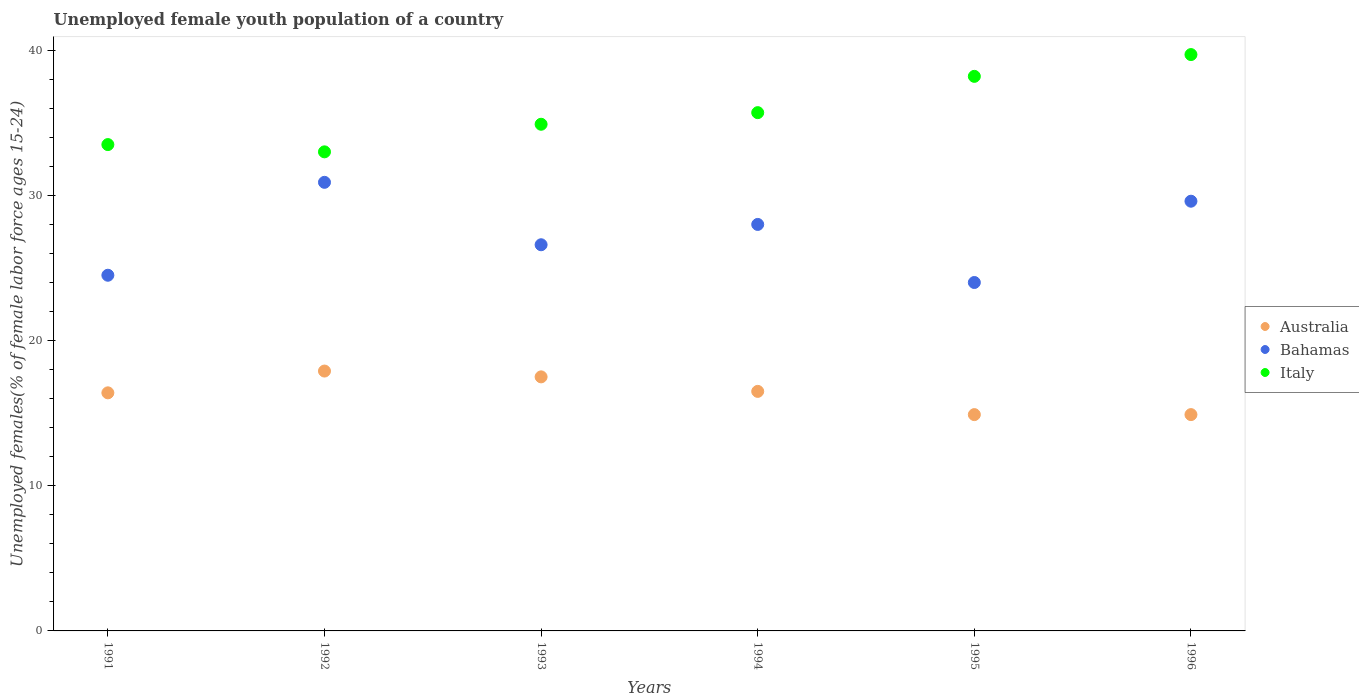Is the number of dotlines equal to the number of legend labels?
Your answer should be compact. Yes. What is the percentage of unemployed female youth population in Italy in 1991?
Offer a terse response. 33.5. Across all years, what is the maximum percentage of unemployed female youth population in Australia?
Your answer should be very brief. 17.9. Across all years, what is the minimum percentage of unemployed female youth population in Australia?
Make the answer very short. 14.9. In which year was the percentage of unemployed female youth population in Australia minimum?
Offer a terse response. 1995. What is the total percentage of unemployed female youth population in Italy in the graph?
Offer a terse response. 215. What is the difference between the percentage of unemployed female youth population in Italy in 1991 and that in 1993?
Provide a succinct answer. -1.4. What is the difference between the percentage of unemployed female youth population in Italy in 1991 and the percentage of unemployed female youth population in Bahamas in 1996?
Give a very brief answer. 3.9. What is the average percentage of unemployed female youth population in Australia per year?
Provide a short and direct response. 16.35. In the year 1995, what is the difference between the percentage of unemployed female youth population in Bahamas and percentage of unemployed female youth population in Italy?
Offer a terse response. -14.2. What is the ratio of the percentage of unemployed female youth population in Australia in 1991 to that in 1993?
Provide a succinct answer. 0.94. Is the percentage of unemployed female youth population in Australia in 1991 less than that in 1992?
Make the answer very short. Yes. What is the difference between the highest and the second highest percentage of unemployed female youth population in Australia?
Make the answer very short. 0.4. What is the difference between the highest and the lowest percentage of unemployed female youth population in Australia?
Make the answer very short. 3. Is it the case that in every year, the sum of the percentage of unemployed female youth population in Australia and percentage of unemployed female youth population in Bahamas  is greater than the percentage of unemployed female youth population in Italy?
Offer a terse response. Yes. Is the percentage of unemployed female youth population in Italy strictly less than the percentage of unemployed female youth population in Bahamas over the years?
Provide a short and direct response. No. How many dotlines are there?
Provide a short and direct response. 3. How many years are there in the graph?
Keep it short and to the point. 6. What is the difference between two consecutive major ticks on the Y-axis?
Your answer should be very brief. 10. Does the graph contain grids?
Give a very brief answer. No. What is the title of the graph?
Make the answer very short. Unemployed female youth population of a country. Does "Papua New Guinea" appear as one of the legend labels in the graph?
Your answer should be compact. No. What is the label or title of the X-axis?
Offer a very short reply. Years. What is the label or title of the Y-axis?
Provide a short and direct response. Unemployed females(% of female labor force ages 15-24). What is the Unemployed females(% of female labor force ages 15-24) in Australia in 1991?
Your answer should be very brief. 16.4. What is the Unemployed females(% of female labor force ages 15-24) in Italy in 1991?
Make the answer very short. 33.5. What is the Unemployed females(% of female labor force ages 15-24) of Australia in 1992?
Your response must be concise. 17.9. What is the Unemployed females(% of female labor force ages 15-24) in Bahamas in 1992?
Keep it short and to the point. 30.9. What is the Unemployed females(% of female labor force ages 15-24) in Italy in 1992?
Make the answer very short. 33. What is the Unemployed females(% of female labor force ages 15-24) in Bahamas in 1993?
Provide a short and direct response. 26.6. What is the Unemployed females(% of female labor force ages 15-24) in Italy in 1993?
Offer a very short reply. 34.9. What is the Unemployed females(% of female labor force ages 15-24) in Bahamas in 1994?
Give a very brief answer. 28. What is the Unemployed females(% of female labor force ages 15-24) of Italy in 1994?
Make the answer very short. 35.7. What is the Unemployed females(% of female labor force ages 15-24) in Australia in 1995?
Your response must be concise. 14.9. What is the Unemployed females(% of female labor force ages 15-24) in Bahamas in 1995?
Provide a short and direct response. 24. What is the Unemployed females(% of female labor force ages 15-24) in Italy in 1995?
Keep it short and to the point. 38.2. What is the Unemployed females(% of female labor force ages 15-24) in Australia in 1996?
Ensure brevity in your answer.  14.9. What is the Unemployed females(% of female labor force ages 15-24) of Bahamas in 1996?
Your answer should be compact. 29.6. What is the Unemployed females(% of female labor force ages 15-24) in Italy in 1996?
Your response must be concise. 39.7. Across all years, what is the maximum Unemployed females(% of female labor force ages 15-24) of Australia?
Make the answer very short. 17.9. Across all years, what is the maximum Unemployed females(% of female labor force ages 15-24) in Bahamas?
Your answer should be very brief. 30.9. Across all years, what is the maximum Unemployed females(% of female labor force ages 15-24) of Italy?
Provide a succinct answer. 39.7. Across all years, what is the minimum Unemployed females(% of female labor force ages 15-24) of Australia?
Ensure brevity in your answer.  14.9. Across all years, what is the minimum Unemployed females(% of female labor force ages 15-24) of Bahamas?
Your answer should be compact. 24. Across all years, what is the minimum Unemployed females(% of female labor force ages 15-24) of Italy?
Keep it short and to the point. 33. What is the total Unemployed females(% of female labor force ages 15-24) of Australia in the graph?
Your response must be concise. 98.1. What is the total Unemployed females(% of female labor force ages 15-24) of Bahamas in the graph?
Offer a very short reply. 163.6. What is the total Unemployed females(% of female labor force ages 15-24) of Italy in the graph?
Keep it short and to the point. 215. What is the difference between the Unemployed females(% of female labor force ages 15-24) of Italy in 1991 and that in 1992?
Offer a terse response. 0.5. What is the difference between the Unemployed females(% of female labor force ages 15-24) of Australia in 1991 and that in 1994?
Your answer should be compact. -0.1. What is the difference between the Unemployed females(% of female labor force ages 15-24) of Italy in 1991 and that in 1994?
Make the answer very short. -2.2. What is the difference between the Unemployed females(% of female labor force ages 15-24) of Italy in 1991 and that in 1995?
Ensure brevity in your answer.  -4.7. What is the difference between the Unemployed females(% of female labor force ages 15-24) of Italy in 1991 and that in 1996?
Offer a very short reply. -6.2. What is the difference between the Unemployed females(% of female labor force ages 15-24) of Italy in 1992 and that in 1994?
Offer a very short reply. -2.7. What is the difference between the Unemployed females(% of female labor force ages 15-24) of Bahamas in 1992 and that in 1995?
Provide a succinct answer. 6.9. What is the difference between the Unemployed females(% of female labor force ages 15-24) of Italy in 1992 and that in 1995?
Provide a succinct answer. -5.2. What is the difference between the Unemployed females(% of female labor force ages 15-24) of Australia in 1992 and that in 1996?
Ensure brevity in your answer.  3. What is the difference between the Unemployed females(% of female labor force ages 15-24) of Bahamas in 1992 and that in 1996?
Give a very brief answer. 1.3. What is the difference between the Unemployed females(% of female labor force ages 15-24) of Italy in 1992 and that in 1996?
Ensure brevity in your answer.  -6.7. What is the difference between the Unemployed females(% of female labor force ages 15-24) of Bahamas in 1993 and that in 1995?
Give a very brief answer. 2.6. What is the difference between the Unemployed females(% of female labor force ages 15-24) of Italy in 1993 and that in 1995?
Provide a short and direct response. -3.3. What is the difference between the Unemployed females(% of female labor force ages 15-24) of Bahamas in 1993 and that in 1996?
Make the answer very short. -3. What is the difference between the Unemployed females(% of female labor force ages 15-24) of Italy in 1993 and that in 1996?
Your response must be concise. -4.8. What is the difference between the Unemployed females(% of female labor force ages 15-24) of Australia in 1994 and that in 1996?
Your response must be concise. 1.6. What is the difference between the Unemployed females(% of female labor force ages 15-24) in Italy in 1994 and that in 1996?
Provide a succinct answer. -4. What is the difference between the Unemployed females(% of female labor force ages 15-24) of Bahamas in 1995 and that in 1996?
Give a very brief answer. -5.6. What is the difference between the Unemployed females(% of female labor force ages 15-24) of Australia in 1991 and the Unemployed females(% of female labor force ages 15-24) of Bahamas in 1992?
Provide a succinct answer. -14.5. What is the difference between the Unemployed females(% of female labor force ages 15-24) of Australia in 1991 and the Unemployed females(% of female labor force ages 15-24) of Italy in 1992?
Your answer should be compact. -16.6. What is the difference between the Unemployed females(% of female labor force ages 15-24) of Bahamas in 1991 and the Unemployed females(% of female labor force ages 15-24) of Italy in 1992?
Your answer should be compact. -8.5. What is the difference between the Unemployed females(% of female labor force ages 15-24) of Australia in 1991 and the Unemployed females(% of female labor force ages 15-24) of Italy in 1993?
Your response must be concise. -18.5. What is the difference between the Unemployed females(% of female labor force ages 15-24) of Australia in 1991 and the Unemployed females(% of female labor force ages 15-24) of Italy in 1994?
Provide a succinct answer. -19.3. What is the difference between the Unemployed females(% of female labor force ages 15-24) of Australia in 1991 and the Unemployed females(% of female labor force ages 15-24) of Bahamas in 1995?
Offer a very short reply. -7.6. What is the difference between the Unemployed females(% of female labor force ages 15-24) of Australia in 1991 and the Unemployed females(% of female labor force ages 15-24) of Italy in 1995?
Your answer should be compact. -21.8. What is the difference between the Unemployed females(% of female labor force ages 15-24) in Bahamas in 1991 and the Unemployed females(% of female labor force ages 15-24) in Italy in 1995?
Make the answer very short. -13.7. What is the difference between the Unemployed females(% of female labor force ages 15-24) in Australia in 1991 and the Unemployed females(% of female labor force ages 15-24) in Bahamas in 1996?
Keep it short and to the point. -13.2. What is the difference between the Unemployed females(% of female labor force ages 15-24) of Australia in 1991 and the Unemployed females(% of female labor force ages 15-24) of Italy in 1996?
Keep it short and to the point. -23.3. What is the difference between the Unemployed females(% of female labor force ages 15-24) in Bahamas in 1991 and the Unemployed females(% of female labor force ages 15-24) in Italy in 1996?
Give a very brief answer. -15.2. What is the difference between the Unemployed females(% of female labor force ages 15-24) of Bahamas in 1992 and the Unemployed females(% of female labor force ages 15-24) of Italy in 1993?
Your response must be concise. -4. What is the difference between the Unemployed females(% of female labor force ages 15-24) in Australia in 1992 and the Unemployed females(% of female labor force ages 15-24) in Bahamas in 1994?
Your answer should be compact. -10.1. What is the difference between the Unemployed females(% of female labor force ages 15-24) of Australia in 1992 and the Unemployed females(% of female labor force ages 15-24) of Italy in 1994?
Offer a very short reply. -17.8. What is the difference between the Unemployed females(% of female labor force ages 15-24) of Bahamas in 1992 and the Unemployed females(% of female labor force ages 15-24) of Italy in 1994?
Your answer should be compact. -4.8. What is the difference between the Unemployed females(% of female labor force ages 15-24) in Australia in 1992 and the Unemployed females(% of female labor force ages 15-24) in Italy in 1995?
Make the answer very short. -20.3. What is the difference between the Unemployed females(% of female labor force ages 15-24) of Australia in 1992 and the Unemployed females(% of female labor force ages 15-24) of Bahamas in 1996?
Your answer should be very brief. -11.7. What is the difference between the Unemployed females(% of female labor force ages 15-24) in Australia in 1992 and the Unemployed females(% of female labor force ages 15-24) in Italy in 1996?
Offer a very short reply. -21.8. What is the difference between the Unemployed females(% of female labor force ages 15-24) in Australia in 1993 and the Unemployed females(% of female labor force ages 15-24) in Bahamas in 1994?
Offer a terse response. -10.5. What is the difference between the Unemployed females(% of female labor force ages 15-24) in Australia in 1993 and the Unemployed females(% of female labor force ages 15-24) in Italy in 1994?
Provide a succinct answer. -18.2. What is the difference between the Unemployed females(% of female labor force ages 15-24) of Australia in 1993 and the Unemployed females(% of female labor force ages 15-24) of Bahamas in 1995?
Keep it short and to the point. -6.5. What is the difference between the Unemployed females(% of female labor force ages 15-24) in Australia in 1993 and the Unemployed females(% of female labor force ages 15-24) in Italy in 1995?
Your answer should be very brief. -20.7. What is the difference between the Unemployed females(% of female labor force ages 15-24) of Bahamas in 1993 and the Unemployed females(% of female labor force ages 15-24) of Italy in 1995?
Your answer should be compact. -11.6. What is the difference between the Unemployed females(% of female labor force ages 15-24) in Australia in 1993 and the Unemployed females(% of female labor force ages 15-24) in Bahamas in 1996?
Keep it short and to the point. -12.1. What is the difference between the Unemployed females(% of female labor force ages 15-24) in Australia in 1993 and the Unemployed females(% of female labor force ages 15-24) in Italy in 1996?
Offer a very short reply. -22.2. What is the difference between the Unemployed females(% of female labor force ages 15-24) of Australia in 1994 and the Unemployed females(% of female labor force ages 15-24) of Italy in 1995?
Your response must be concise. -21.7. What is the difference between the Unemployed females(% of female labor force ages 15-24) of Bahamas in 1994 and the Unemployed females(% of female labor force ages 15-24) of Italy in 1995?
Your response must be concise. -10.2. What is the difference between the Unemployed females(% of female labor force ages 15-24) in Australia in 1994 and the Unemployed females(% of female labor force ages 15-24) in Italy in 1996?
Make the answer very short. -23.2. What is the difference between the Unemployed females(% of female labor force ages 15-24) of Bahamas in 1994 and the Unemployed females(% of female labor force ages 15-24) of Italy in 1996?
Provide a succinct answer. -11.7. What is the difference between the Unemployed females(% of female labor force ages 15-24) in Australia in 1995 and the Unemployed females(% of female labor force ages 15-24) in Bahamas in 1996?
Your response must be concise. -14.7. What is the difference between the Unemployed females(% of female labor force ages 15-24) of Australia in 1995 and the Unemployed females(% of female labor force ages 15-24) of Italy in 1996?
Give a very brief answer. -24.8. What is the difference between the Unemployed females(% of female labor force ages 15-24) in Bahamas in 1995 and the Unemployed females(% of female labor force ages 15-24) in Italy in 1996?
Offer a terse response. -15.7. What is the average Unemployed females(% of female labor force ages 15-24) of Australia per year?
Keep it short and to the point. 16.35. What is the average Unemployed females(% of female labor force ages 15-24) of Bahamas per year?
Make the answer very short. 27.27. What is the average Unemployed females(% of female labor force ages 15-24) in Italy per year?
Provide a short and direct response. 35.83. In the year 1991, what is the difference between the Unemployed females(% of female labor force ages 15-24) in Australia and Unemployed females(% of female labor force ages 15-24) in Italy?
Keep it short and to the point. -17.1. In the year 1992, what is the difference between the Unemployed females(% of female labor force ages 15-24) of Australia and Unemployed females(% of female labor force ages 15-24) of Italy?
Offer a very short reply. -15.1. In the year 1993, what is the difference between the Unemployed females(% of female labor force ages 15-24) of Australia and Unemployed females(% of female labor force ages 15-24) of Italy?
Offer a very short reply. -17.4. In the year 1994, what is the difference between the Unemployed females(% of female labor force ages 15-24) of Australia and Unemployed females(% of female labor force ages 15-24) of Italy?
Provide a short and direct response. -19.2. In the year 1995, what is the difference between the Unemployed females(% of female labor force ages 15-24) of Australia and Unemployed females(% of female labor force ages 15-24) of Bahamas?
Give a very brief answer. -9.1. In the year 1995, what is the difference between the Unemployed females(% of female labor force ages 15-24) in Australia and Unemployed females(% of female labor force ages 15-24) in Italy?
Keep it short and to the point. -23.3. In the year 1996, what is the difference between the Unemployed females(% of female labor force ages 15-24) in Australia and Unemployed females(% of female labor force ages 15-24) in Bahamas?
Ensure brevity in your answer.  -14.7. In the year 1996, what is the difference between the Unemployed females(% of female labor force ages 15-24) of Australia and Unemployed females(% of female labor force ages 15-24) of Italy?
Keep it short and to the point. -24.8. In the year 1996, what is the difference between the Unemployed females(% of female labor force ages 15-24) of Bahamas and Unemployed females(% of female labor force ages 15-24) of Italy?
Offer a very short reply. -10.1. What is the ratio of the Unemployed females(% of female labor force ages 15-24) in Australia in 1991 to that in 1992?
Your answer should be compact. 0.92. What is the ratio of the Unemployed females(% of female labor force ages 15-24) of Bahamas in 1991 to that in 1992?
Make the answer very short. 0.79. What is the ratio of the Unemployed females(% of female labor force ages 15-24) in Italy in 1991 to that in 1992?
Give a very brief answer. 1.02. What is the ratio of the Unemployed females(% of female labor force ages 15-24) of Australia in 1991 to that in 1993?
Provide a short and direct response. 0.94. What is the ratio of the Unemployed females(% of female labor force ages 15-24) of Bahamas in 1991 to that in 1993?
Provide a short and direct response. 0.92. What is the ratio of the Unemployed females(% of female labor force ages 15-24) in Italy in 1991 to that in 1993?
Offer a very short reply. 0.96. What is the ratio of the Unemployed females(% of female labor force ages 15-24) of Australia in 1991 to that in 1994?
Your answer should be very brief. 0.99. What is the ratio of the Unemployed females(% of female labor force ages 15-24) in Bahamas in 1991 to that in 1994?
Your answer should be compact. 0.88. What is the ratio of the Unemployed females(% of female labor force ages 15-24) in Italy in 1991 to that in 1994?
Make the answer very short. 0.94. What is the ratio of the Unemployed females(% of female labor force ages 15-24) in Australia in 1991 to that in 1995?
Your answer should be compact. 1.1. What is the ratio of the Unemployed females(% of female labor force ages 15-24) of Bahamas in 1991 to that in 1995?
Your response must be concise. 1.02. What is the ratio of the Unemployed females(% of female labor force ages 15-24) in Italy in 1991 to that in 1995?
Your answer should be compact. 0.88. What is the ratio of the Unemployed females(% of female labor force ages 15-24) of Australia in 1991 to that in 1996?
Make the answer very short. 1.1. What is the ratio of the Unemployed females(% of female labor force ages 15-24) of Bahamas in 1991 to that in 1996?
Ensure brevity in your answer.  0.83. What is the ratio of the Unemployed females(% of female labor force ages 15-24) of Italy in 1991 to that in 1996?
Ensure brevity in your answer.  0.84. What is the ratio of the Unemployed females(% of female labor force ages 15-24) of Australia in 1992 to that in 1993?
Provide a short and direct response. 1.02. What is the ratio of the Unemployed females(% of female labor force ages 15-24) in Bahamas in 1992 to that in 1993?
Provide a short and direct response. 1.16. What is the ratio of the Unemployed females(% of female labor force ages 15-24) of Italy in 1992 to that in 1993?
Give a very brief answer. 0.95. What is the ratio of the Unemployed females(% of female labor force ages 15-24) in Australia in 1992 to that in 1994?
Offer a terse response. 1.08. What is the ratio of the Unemployed females(% of female labor force ages 15-24) of Bahamas in 1992 to that in 1994?
Offer a very short reply. 1.1. What is the ratio of the Unemployed females(% of female labor force ages 15-24) in Italy in 1992 to that in 1994?
Give a very brief answer. 0.92. What is the ratio of the Unemployed females(% of female labor force ages 15-24) of Australia in 1992 to that in 1995?
Your answer should be very brief. 1.2. What is the ratio of the Unemployed females(% of female labor force ages 15-24) of Bahamas in 1992 to that in 1995?
Keep it short and to the point. 1.29. What is the ratio of the Unemployed females(% of female labor force ages 15-24) of Italy in 1992 to that in 1995?
Give a very brief answer. 0.86. What is the ratio of the Unemployed females(% of female labor force ages 15-24) in Australia in 1992 to that in 1996?
Offer a very short reply. 1.2. What is the ratio of the Unemployed females(% of female labor force ages 15-24) in Bahamas in 1992 to that in 1996?
Provide a short and direct response. 1.04. What is the ratio of the Unemployed females(% of female labor force ages 15-24) of Italy in 1992 to that in 1996?
Keep it short and to the point. 0.83. What is the ratio of the Unemployed females(% of female labor force ages 15-24) in Australia in 1993 to that in 1994?
Your response must be concise. 1.06. What is the ratio of the Unemployed females(% of female labor force ages 15-24) of Italy in 1993 to that in 1994?
Your answer should be compact. 0.98. What is the ratio of the Unemployed females(% of female labor force ages 15-24) in Australia in 1993 to that in 1995?
Ensure brevity in your answer.  1.17. What is the ratio of the Unemployed females(% of female labor force ages 15-24) in Bahamas in 1993 to that in 1995?
Make the answer very short. 1.11. What is the ratio of the Unemployed females(% of female labor force ages 15-24) in Italy in 1993 to that in 1995?
Offer a very short reply. 0.91. What is the ratio of the Unemployed females(% of female labor force ages 15-24) in Australia in 1993 to that in 1996?
Your answer should be compact. 1.17. What is the ratio of the Unemployed females(% of female labor force ages 15-24) of Bahamas in 1993 to that in 1996?
Offer a very short reply. 0.9. What is the ratio of the Unemployed females(% of female labor force ages 15-24) of Italy in 1993 to that in 1996?
Provide a short and direct response. 0.88. What is the ratio of the Unemployed females(% of female labor force ages 15-24) of Australia in 1994 to that in 1995?
Your response must be concise. 1.11. What is the ratio of the Unemployed females(% of female labor force ages 15-24) in Italy in 1994 to that in 1995?
Make the answer very short. 0.93. What is the ratio of the Unemployed females(% of female labor force ages 15-24) of Australia in 1994 to that in 1996?
Provide a short and direct response. 1.11. What is the ratio of the Unemployed females(% of female labor force ages 15-24) in Bahamas in 1994 to that in 1996?
Your answer should be compact. 0.95. What is the ratio of the Unemployed females(% of female labor force ages 15-24) in Italy in 1994 to that in 1996?
Offer a terse response. 0.9. What is the ratio of the Unemployed females(% of female labor force ages 15-24) in Australia in 1995 to that in 1996?
Keep it short and to the point. 1. What is the ratio of the Unemployed females(% of female labor force ages 15-24) of Bahamas in 1995 to that in 1996?
Your answer should be compact. 0.81. What is the ratio of the Unemployed females(% of female labor force ages 15-24) in Italy in 1995 to that in 1996?
Provide a succinct answer. 0.96. What is the difference between the highest and the second highest Unemployed females(% of female labor force ages 15-24) of Bahamas?
Offer a terse response. 1.3. What is the difference between the highest and the lowest Unemployed females(% of female labor force ages 15-24) of Australia?
Your answer should be compact. 3. What is the difference between the highest and the lowest Unemployed females(% of female labor force ages 15-24) in Bahamas?
Your answer should be very brief. 6.9. What is the difference between the highest and the lowest Unemployed females(% of female labor force ages 15-24) in Italy?
Offer a very short reply. 6.7. 